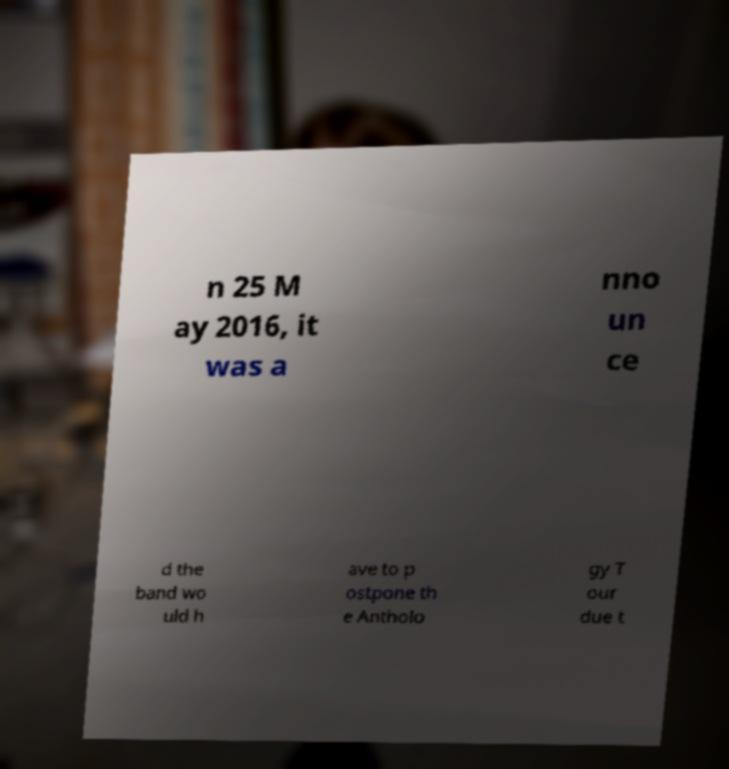I need the written content from this picture converted into text. Can you do that? n 25 M ay 2016, it was a nno un ce d the band wo uld h ave to p ostpone th e Antholo gy T our due t 